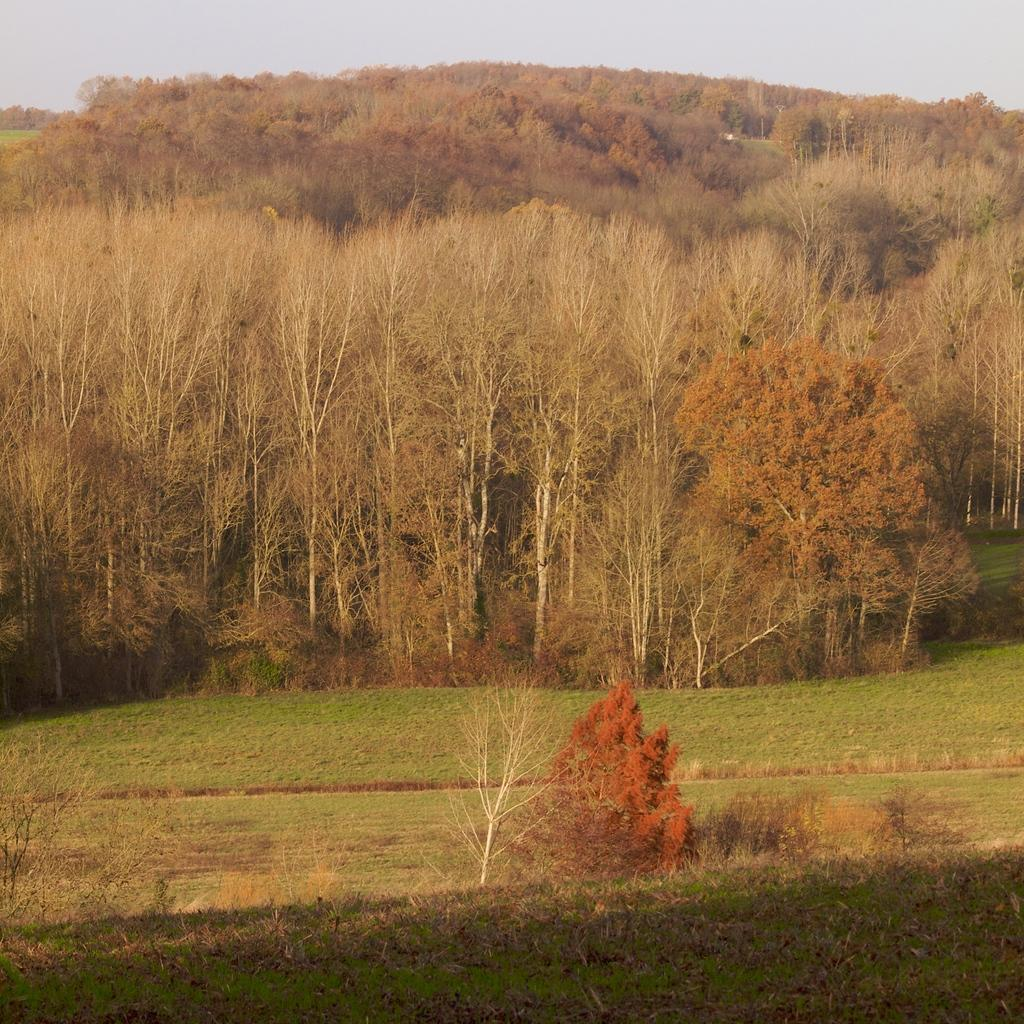What type of vegetation can be seen in the image? There is grass, plants, and trees in the image. What part of the natural environment is visible in the image? The sky is visible in the image. Can you describe the vegetation in the image? The image contains grass, plants, and trees. What type of eggnog is being served in the image? There is no eggnog present in the image; it features grass, plants, trees, and the sky. How many ducks can be seen swimming in the image? There are no ducks present in the image. 